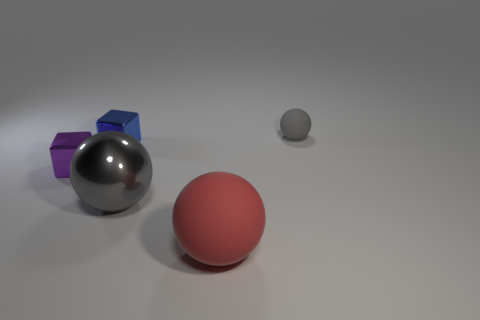Subtract all yellow cubes. Subtract all cyan cylinders. How many cubes are left? 2 Add 2 large red objects. How many objects exist? 7 Subtract all balls. How many objects are left? 2 Add 5 large things. How many large things exist? 7 Subtract 0 red cubes. How many objects are left? 5 Subtract all purple blocks. Subtract all green metal cubes. How many objects are left? 4 Add 2 gray metallic things. How many gray metallic things are left? 3 